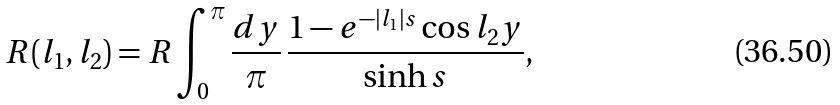Convert formula to latex. <formula><loc_0><loc_0><loc_500><loc_500>R ( l _ { 1 } , l _ { 2 } ) = R \int _ { 0 } ^ { \pi } \frac { d y } { \pi } \, \frac { 1 - e ^ { - \left | l _ { 1 } \right | s } \cos l _ { 2 } y } { \sinh s } ,</formula> 